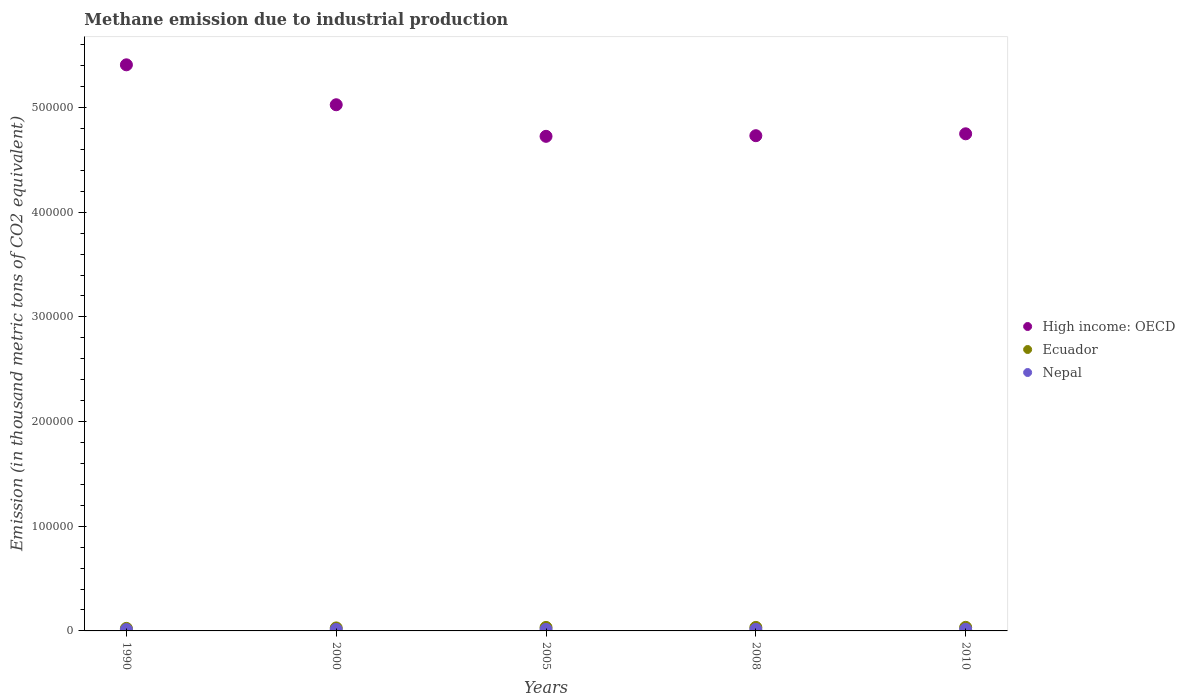What is the amount of methane emitted in High income: OECD in 2005?
Your answer should be compact. 4.73e+05. Across all years, what is the maximum amount of methane emitted in Nepal?
Keep it short and to the point. 1515.7. Across all years, what is the minimum amount of methane emitted in Ecuador?
Make the answer very short. 2418.4. In which year was the amount of methane emitted in High income: OECD minimum?
Give a very brief answer. 2005. What is the total amount of methane emitted in High income: OECD in the graph?
Make the answer very short. 2.46e+06. What is the difference between the amount of methane emitted in Ecuador in 1990 and that in 2005?
Your answer should be very brief. -936.3. What is the difference between the amount of methane emitted in Ecuador in 2000 and the amount of methane emitted in Nepal in 2005?
Offer a terse response. 1430.3. What is the average amount of methane emitted in Ecuador per year?
Make the answer very short. 3085.26. In the year 2000, what is the difference between the amount of methane emitted in Ecuador and amount of methane emitted in Nepal?
Your answer should be compact. 1461. In how many years, is the amount of methane emitted in High income: OECD greater than 520000 thousand metric tons?
Ensure brevity in your answer.  1. What is the ratio of the amount of methane emitted in Nepal in 2000 to that in 2008?
Provide a succinct answer. 0.96. Is the amount of methane emitted in Ecuador in 2008 less than that in 2010?
Make the answer very short. Yes. Is the difference between the amount of methane emitted in Ecuador in 2000 and 2005 greater than the difference between the amount of methane emitted in Nepal in 2000 and 2005?
Offer a terse response. No. What is the difference between the highest and the second highest amount of methane emitted in Nepal?
Keep it short and to the point. 57.1. What is the difference between the highest and the lowest amount of methane emitted in High income: OECD?
Offer a terse response. 6.83e+04. In how many years, is the amount of methane emitted in High income: OECD greater than the average amount of methane emitted in High income: OECD taken over all years?
Ensure brevity in your answer.  2. Is the sum of the amount of methane emitted in Nepal in 2005 and 2010 greater than the maximum amount of methane emitted in Ecuador across all years?
Provide a short and direct response. No. Is the amount of methane emitted in Nepal strictly less than the amount of methane emitted in Ecuador over the years?
Your answer should be compact. Yes. How many dotlines are there?
Provide a short and direct response. 3. How many years are there in the graph?
Ensure brevity in your answer.  5. Does the graph contain grids?
Offer a terse response. No. Where does the legend appear in the graph?
Offer a very short reply. Center right. How are the legend labels stacked?
Your response must be concise. Vertical. What is the title of the graph?
Provide a short and direct response. Methane emission due to industrial production. Does "Sao Tome and Principe" appear as one of the legend labels in the graph?
Make the answer very short. No. What is the label or title of the Y-axis?
Your answer should be very brief. Emission (in thousand metric tons of CO2 equivalent). What is the Emission (in thousand metric tons of CO2 equivalent) in High income: OECD in 1990?
Provide a short and direct response. 5.41e+05. What is the Emission (in thousand metric tons of CO2 equivalent) in Ecuador in 1990?
Your answer should be compact. 2418.4. What is the Emission (in thousand metric tons of CO2 equivalent) in Nepal in 1990?
Offer a terse response. 1296.6. What is the Emission (in thousand metric tons of CO2 equivalent) of High income: OECD in 2000?
Ensure brevity in your answer.  5.03e+05. What is the Emission (in thousand metric tons of CO2 equivalent) in Ecuador in 2000?
Ensure brevity in your answer.  2866.1. What is the Emission (in thousand metric tons of CO2 equivalent) of Nepal in 2000?
Your answer should be very brief. 1405.1. What is the Emission (in thousand metric tons of CO2 equivalent) of High income: OECD in 2005?
Provide a succinct answer. 4.73e+05. What is the Emission (in thousand metric tons of CO2 equivalent) in Ecuador in 2005?
Make the answer very short. 3354.7. What is the Emission (in thousand metric tons of CO2 equivalent) of Nepal in 2005?
Give a very brief answer. 1435.8. What is the Emission (in thousand metric tons of CO2 equivalent) of High income: OECD in 2008?
Provide a short and direct response. 4.73e+05. What is the Emission (in thousand metric tons of CO2 equivalent) of Ecuador in 2008?
Your response must be concise. 3354.3. What is the Emission (in thousand metric tons of CO2 equivalent) in Nepal in 2008?
Keep it short and to the point. 1458.6. What is the Emission (in thousand metric tons of CO2 equivalent) in High income: OECD in 2010?
Your answer should be compact. 4.75e+05. What is the Emission (in thousand metric tons of CO2 equivalent) of Ecuador in 2010?
Your answer should be very brief. 3432.8. What is the Emission (in thousand metric tons of CO2 equivalent) of Nepal in 2010?
Your response must be concise. 1515.7. Across all years, what is the maximum Emission (in thousand metric tons of CO2 equivalent) in High income: OECD?
Provide a short and direct response. 5.41e+05. Across all years, what is the maximum Emission (in thousand metric tons of CO2 equivalent) of Ecuador?
Keep it short and to the point. 3432.8. Across all years, what is the maximum Emission (in thousand metric tons of CO2 equivalent) in Nepal?
Provide a succinct answer. 1515.7. Across all years, what is the minimum Emission (in thousand metric tons of CO2 equivalent) in High income: OECD?
Offer a terse response. 4.73e+05. Across all years, what is the minimum Emission (in thousand metric tons of CO2 equivalent) in Ecuador?
Your response must be concise. 2418.4. Across all years, what is the minimum Emission (in thousand metric tons of CO2 equivalent) in Nepal?
Your response must be concise. 1296.6. What is the total Emission (in thousand metric tons of CO2 equivalent) in High income: OECD in the graph?
Your answer should be very brief. 2.46e+06. What is the total Emission (in thousand metric tons of CO2 equivalent) of Ecuador in the graph?
Provide a short and direct response. 1.54e+04. What is the total Emission (in thousand metric tons of CO2 equivalent) of Nepal in the graph?
Offer a terse response. 7111.8. What is the difference between the Emission (in thousand metric tons of CO2 equivalent) in High income: OECD in 1990 and that in 2000?
Offer a terse response. 3.82e+04. What is the difference between the Emission (in thousand metric tons of CO2 equivalent) in Ecuador in 1990 and that in 2000?
Make the answer very short. -447.7. What is the difference between the Emission (in thousand metric tons of CO2 equivalent) in Nepal in 1990 and that in 2000?
Your response must be concise. -108.5. What is the difference between the Emission (in thousand metric tons of CO2 equivalent) of High income: OECD in 1990 and that in 2005?
Give a very brief answer. 6.83e+04. What is the difference between the Emission (in thousand metric tons of CO2 equivalent) of Ecuador in 1990 and that in 2005?
Your answer should be compact. -936.3. What is the difference between the Emission (in thousand metric tons of CO2 equivalent) of Nepal in 1990 and that in 2005?
Keep it short and to the point. -139.2. What is the difference between the Emission (in thousand metric tons of CO2 equivalent) in High income: OECD in 1990 and that in 2008?
Your response must be concise. 6.77e+04. What is the difference between the Emission (in thousand metric tons of CO2 equivalent) in Ecuador in 1990 and that in 2008?
Make the answer very short. -935.9. What is the difference between the Emission (in thousand metric tons of CO2 equivalent) of Nepal in 1990 and that in 2008?
Keep it short and to the point. -162. What is the difference between the Emission (in thousand metric tons of CO2 equivalent) in High income: OECD in 1990 and that in 2010?
Offer a very short reply. 6.59e+04. What is the difference between the Emission (in thousand metric tons of CO2 equivalent) in Ecuador in 1990 and that in 2010?
Provide a short and direct response. -1014.4. What is the difference between the Emission (in thousand metric tons of CO2 equivalent) of Nepal in 1990 and that in 2010?
Your response must be concise. -219.1. What is the difference between the Emission (in thousand metric tons of CO2 equivalent) in High income: OECD in 2000 and that in 2005?
Offer a very short reply. 3.02e+04. What is the difference between the Emission (in thousand metric tons of CO2 equivalent) of Ecuador in 2000 and that in 2005?
Your response must be concise. -488.6. What is the difference between the Emission (in thousand metric tons of CO2 equivalent) of Nepal in 2000 and that in 2005?
Make the answer very short. -30.7. What is the difference between the Emission (in thousand metric tons of CO2 equivalent) in High income: OECD in 2000 and that in 2008?
Your response must be concise. 2.96e+04. What is the difference between the Emission (in thousand metric tons of CO2 equivalent) in Ecuador in 2000 and that in 2008?
Make the answer very short. -488.2. What is the difference between the Emission (in thousand metric tons of CO2 equivalent) in Nepal in 2000 and that in 2008?
Your response must be concise. -53.5. What is the difference between the Emission (in thousand metric tons of CO2 equivalent) of High income: OECD in 2000 and that in 2010?
Offer a very short reply. 2.78e+04. What is the difference between the Emission (in thousand metric tons of CO2 equivalent) in Ecuador in 2000 and that in 2010?
Ensure brevity in your answer.  -566.7. What is the difference between the Emission (in thousand metric tons of CO2 equivalent) in Nepal in 2000 and that in 2010?
Ensure brevity in your answer.  -110.6. What is the difference between the Emission (in thousand metric tons of CO2 equivalent) in High income: OECD in 2005 and that in 2008?
Provide a short and direct response. -593. What is the difference between the Emission (in thousand metric tons of CO2 equivalent) of Ecuador in 2005 and that in 2008?
Give a very brief answer. 0.4. What is the difference between the Emission (in thousand metric tons of CO2 equivalent) in Nepal in 2005 and that in 2008?
Make the answer very short. -22.8. What is the difference between the Emission (in thousand metric tons of CO2 equivalent) in High income: OECD in 2005 and that in 2010?
Make the answer very short. -2407.6. What is the difference between the Emission (in thousand metric tons of CO2 equivalent) of Ecuador in 2005 and that in 2010?
Keep it short and to the point. -78.1. What is the difference between the Emission (in thousand metric tons of CO2 equivalent) of Nepal in 2005 and that in 2010?
Your answer should be compact. -79.9. What is the difference between the Emission (in thousand metric tons of CO2 equivalent) of High income: OECD in 2008 and that in 2010?
Provide a short and direct response. -1814.6. What is the difference between the Emission (in thousand metric tons of CO2 equivalent) of Ecuador in 2008 and that in 2010?
Your answer should be very brief. -78.5. What is the difference between the Emission (in thousand metric tons of CO2 equivalent) in Nepal in 2008 and that in 2010?
Make the answer very short. -57.1. What is the difference between the Emission (in thousand metric tons of CO2 equivalent) in High income: OECD in 1990 and the Emission (in thousand metric tons of CO2 equivalent) in Ecuador in 2000?
Offer a terse response. 5.38e+05. What is the difference between the Emission (in thousand metric tons of CO2 equivalent) in High income: OECD in 1990 and the Emission (in thousand metric tons of CO2 equivalent) in Nepal in 2000?
Your answer should be very brief. 5.39e+05. What is the difference between the Emission (in thousand metric tons of CO2 equivalent) of Ecuador in 1990 and the Emission (in thousand metric tons of CO2 equivalent) of Nepal in 2000?
Your answer should be compact. 1013.3. What is the difference between the Emission (in thousand metric tons of CO2 equivalent) in High income: OECD in 1990 and the Emission (in thousand metric tons of CO2 equivalent) in Ecuador in 2005?
Your answer should be compact. 5.38e+05. What is the difference between the Emission (in thousand metric tons of CO2 equivalent) in High income: OECD in 1990 and the Emission (in thousand metric tons of CO2 equivalent) in Nepal in 2005?
Offer a terse response. 5.39e+05. What is the difference between the Emission (in thousand metric tons of CO2 equivalent) in Ecuador in 1990 and the Emission (in thousand metric tons of CO2 equivalent) in Nepal in 2005?
Your answer should be very brief. 982.6. What is the difference between the Emission (in thousand metric tons of CO2 equivalent) of High income: OECD in 1990 and the Emission (in thousand metric tons of CO2 equivalent) of Ecuador in 2008?
Provide a short and direct response. 5.38e+05. What is the difference between the Emission (in thousand metric tons of CO2 equivalent) of High income: OECD in 1990 and the Emission (in thousand metric tons of CO2 equivalent) of Nepal in 2008?
Keep it short and to the point. 5.39e+05. What is the difference between the Emission (in thousand metric tons of CO2 equivalent) of Ecuador in 1990 and the Emission (in thousand metric tons of CO2 equivalent) of Nepal in 2008?
Provide a succinct answer. 959.8. What is the difference between the Emission (in thousand metric tons of CO2 equivalent) of High income: OECD in 1990 and the Emission (in thousand metric tons of CO2 equivalent) of Ecuador in 2010?
Your answer should be compact. 5.37e+05. What is the difference between the Emission (in thousand metric tons of CO2 equivalent) in High income: OECD in 1990 and the Emission (in thousand metric tons of CO2 equivalent) in Nepal in 2010?
Your answer should be compact. 5.39e+05. What is the difference between the Emission (in thousand metric tons of CO2 equivalent) of Ecuador in 1990 and the Emission (in thousand metric tons of CO2 equivalent) of Nepal in 2010?
Make the answer very short. 902.7. What is the difference between the Emission (in thousand metric tons of CO2 equivalent) of High income: OECD in 2000 and the Emission (in thousand metric tons of CO2 equivalent) of Ecuador in 2005?
Provide a short and direct response. 4.99e+05. What is the difference between the Emission (in thousand metric tons of CO2 equivalent) of High income: OECD in 2000 and the Emission (in thousand metric tons of CO2 equivalent) of Nepal in 2005?
Offer a terse response. 5.01e+05. What is the difference between the Emission (in thousand metric tons of CO2 equivalent) of Ecuador in 2000 and the Emission (in thousand metric tons of CO2 equivalent) of Nepal in 2005?
Ensure brevity in your answer.  1430.3. What is the difference between the Emission (in thousand metric tons of CO2 equivalent) in High income: OECD in 2000 and the Emission (in thousand metric tons of CO2 equivalent) in Ecuador in 2008?
Keep it short and to the point. 4.99e+05. What is the difference between the Emission (in thousand metric tons of CO2 equivalent) of High income: OECD in 2000 and the Emission (in thousand metric tons of CO2 equivalent) of Nepal in 2008?
Offer a terse response. 5.01e+05. What is the difference between the Emission (in thousand metric tons of CO2 equivalent) of Ecuador in 2000 and the Emission (in thousand metric tons of CO2 equivalent) of Nepal in 2008?
Provide a succinct answer. 1407.5. What is the difference between the Emission (in thousand metric tons of CO2 equivalent) of High income: OECD in 2000 and the Emission (in thousand metric tons of CO2 equivalent) of Ecuador in 2010?
Ensure brevity in your answer.  4.99e+05. What is the difference between the Emission (in thousand metric tons of CO2 equivalent) in High income: OECD in 2000 and the Emission (in thousand metric tons of CO2 equivalent) in Nepal in 2010?
Provide a short and direct response. 5.01e+05. What is the difference between the Emission (in thousand metric tons of CO2 equivalent) in Ecuador in 2000 and the Emission (in thousand metric tons of CO2 equivalent) in Nepal in 2010?
Offer a very short reply. 1350.4. What is the difference between the Emission (in thousand metric tons of CO2 equivalent) of High income: OECD in 2005 and the Emission (in thousand metric tons of CO2 equivalent) of Ecuador in 2008?
Make the answer very short. 4.69e+05. What is the difference between the Emission (in thousand metric tons of CO2 equivalent) of High income: OECD in 2005 and the Emission (in thousand metric tons of CO2 equivalent) of Nepal in 2008?
Offer a terse response. 4.71e+05. What is the difference between the Emission (in thousand metric tons of CO2 equivalent) of Ecuador in 2005 and the Emission (in thousand metric tons of CO2 equivalent) of Nepal in 2008?
Ensure brevity in your answer.  1896.1. What is the difference between the Emission (in thousand metric tons of CO2 equivalent) in High income: OECD in 2005 and the Emission (in thousand metric tons of CO2 equivalent) in Ecuador in 2010?
Your response must be concise. 4.69e+05. What is the difference between the Emission (in thousand metric tons of CO2 equivalent) of High income: OECD in 2005 and the Emission (in thousand metric tons of CO2 equivalent) of Nepal in 2010?
Keep it short and to the point. 4.71e+05. What is the difference between the Emission (in thousand metric tons of CO2 equivalent) in Ecuador in 2005 and the Emission (in thousand metric tons of CO2 equivalent) in Nepal in 2010?
Provide a succinct answer. 1839. What is the difference between the Emission (in thousand metric tons of CO2 equivalent) of High income: OECD in 2008 and the Emission (in thousand metric tons of CO2 equivalent) of Ecuador in 2010?
Provide a succinct answer. 4.70e+05. What is the difference between the Emission (in thousand metric tons of CO2 equivalent) of High income: OECD in 2008 and the Emission (in thousand metric tons of CO2 equivalent) of Nepal in 2010?
Offer a very short reply. 4.72e+05. What is the difference between the Emission (in thousand metric tons of CO2 equivalent) of Ecuador in 2008 and the Emission (in thousand metric tons of CO2 equivalent) of Nepal in 2010?
Provide a short and direct response. 1838.6. What is the average Emission (in thousand metric tons of CO2 equivalent) of High income: OECD per year?
Your answer should be very brief. 4.93e+05. What is the average Emission (in thousand metric tons of CO2 equivalent) in Ecuador per year?
Keep it short and to the point. 3085.26. What is the average Emission (in thousand metric tons of CO2 equivalent) of Nepal per year?
Keep it short and to the point. 1422.36. In the year 1990, what is the difference between the Emission (in thousand metric tons of CO2 equivalent) in High income: OECD and Emission (in thousand metric tons of CO2 equivalent) in Ecuador?
Your answer should be very brief. 5.38e+05. In the year 1990, what is the difference between the Emission (in thousand metric tons of CO2 equivalent) in High income: OECD and Emission (in thousand metric tons of CO2 equivalent) in Nepal?
Offer a very short reply. 5.40e+05. In the year 1990, what is the difference between the Emission (in thousand metric tons of CO2 equivalent) of Ecuador and Emission (in thousand metric tons of CO2 equivalent) of Nepal?
Ensure brevity in your answer.  1121.8. In the year 2000, what is the difference between the Emission (in thousand metric tons of CO2 equivalent) of High income: OECD and Emission (in thousand metric tons of CO2 equivalent) of Ecuador?
Your answer should be compact. 5.00e+05. In the year 2000, what is the difference between the Emission (in thousand metric tons of CO2 equivalent) of High income: OECD and Emission (in thousand metric tons of CO2 equivalent) of Nepal?
Your answer should be very brief. 5.01e+05. In the year 2000, what is the difference between the Emission (in thousand metric tons of CO2 equivalent) of Ecuador and Emission (in thousand metric tons of CO2 equivalent) of Nepal?
Offer a terse response. 1461. In the year 2005, what is the difference between the Emission (in thousand metric tons of CO2 equivalent) of High income: OECD and Emission (in thousand metric tons of CO2 equivalent) of Ecuador?
Keep it short and to the point. 4.69e+05. In the year 2005, what is the difference between the Emission (in thousand metric tons of CO2 equivalent) of High income: OECD and Emission (in thousand metric tons of CO2 equivalent) of Nepal?
Provide a succinct answer. 4.71e+05. In the year 2005, what is the difference between the Emission (in thousand metric tons of CO2 equivalent) in Ecuador and Emission (in thousand metric tons of CO2 equivalent) in Nepal?
Ensure brevity in your answer.  1918.9. In the year 2008, what is the difference between the Emission (in thousand metric tons of CO2 equivalent) in High income: OECD and Emission (in thousand metric tons of CO2 equivalent) in Ecuador?
Give a very brief answer. 4.70e+05. In the year 2008, what is the difference between the Emission (in thousand metric tons of CO2 equivalent) of High income: OECD and Emission (in thousand metric tons of CO2 equivalent) of Nepal?
Provide a short and direct response. 4.72e+05. In the year 2008, what is the difference between the Emission (in thousand metric tons of CO2 equivalent) in Ecuador and Emission (in thousand metric tons of CO2 equivalent) in Nepal?
Offer a very short reply. 1895.7. In the year 2010, what is the difference between the Emission (in thousand metric tons of CO2 equivalent) of High income: OECD and Emission (in thousand metric tons of CO2 equivalent) of Ecuador?
Your answer should be very brief. 4.72e+05. In the year 2010, what is the difference between the Emission (in thousand metric tons of CO2 equivalent) of High income: OECD and Emission (in thousand metric tons of CO2 equivalent) of Nepal?
Keep it short and to the point. 4.73e+05. In the year 2010, what is the difference between the Emission (in thousand metric tons of CO2 equivalent) of Ecuador and Emission (in thousand metric tons of CO2 equivalent) of Nepal?
Your answer should be very brief. 1917.1. What is the ratio of the Emission (in thousand metric tons of CO2 equivalent) in High income: OECD in 1990 to that in 2000?
Make the answer very short. 1.08. What is the ratio of the Emission (in thousand metric tons of CO2 equivalent) in Ecuador in 1990 to that in 2000?
Your response must be concise. 0.84. What is the ratio of the Emission (in thousand metric tons of CO2 equivalent) of Nepal in 1990 to that in 2000?
Keep it short and to the point. 0.92. What is the ratio of the Emission (in thousand metric tons of CO2 equivalent) of High income: OECD in 1990 to that in 2005?
Offer a very short reply. 1.14. What is the ratio of the Emission (in thousand metric tons of CO2 equivalent) of Ecuador in 1990 to that in 2005?
Your answer should be compact. 0.72. What is the ratio of the Emission (in thousand metric tons of CO2 equivalent) in Nepal in 1990 to that in 2005?
Your answer should be compact. 0.9. What is the ratio of the Emission (in thousand metric tons of CO2 equivalent) in High income: OECD in 1990 to that in 2008?
Give a very brief answer. 1.14. What is the ratio of the Emission (in thousand metric tons of CO2 equivalent) of Ecuador in 1990 to that in 2008?
Give a very brief answer. 0.72. What is the ratio of the Emission (in thousand metric tons of CO2 equivalent) in High income: OECD in 1990 to that in 2010?
Ensure brevity in your answer.  1.14. What is the ratio of the Emission (in thousand metric tons of CO2 equivalent) of Ecuador in 1990 to that in 2010?
Ensure brevity in your answer.  0.7. What is the ratio of the Emission (in thousand metric tons of CO2 equivalent) in Nepal in 1990 to that in 2010?
Provide a short and direct response. 0.86. What is the ratio of the Emission (in thousand metric tons of CO2 equivalent) in High income: OECD in 2000 to that in 2005?
Keep it short and to the point. 1.06. What is the ratio of the Emission (in thousand metric tons of CO2 equivalent) of Ecuador in 2000 to that in 2005?
Provide a succinct answer. 0.85. What is the ratio of the Emission (in thousand metric tons of CO2 equivalent) of Nepal in 2000 to that in 2005?
Provide a succinct answer. 0.98. What is the ratio of the Emission (in thousand metric tons of CO2 equivalent) of High income: OECD in 2000 to that in 2008?
Offer a very short reply. 1.06. What is the ratio of the Emission (in thousand metric tons of CO2 equivalent) in Ecuador in 2000 to that in 2008?
Ensure brevity in your answer.  0.85. What is the ratio of the Emission (in thousand metric tons of CO2 equivalent) of Nepal in 2000 to that in 2008?
Your response must be concise. 0.96. What is the ratio of the Emission (in thousand metric tons of CO2 equivalent) in High income: OECD in 2000 to that in 2010?
Your response must be concise. 1.06. What is the ratio of the Emission (in thousand metric tons of CO2 equivalent) of Ecuador in 2000 to that in 2010?
Offer a very short reply. 0.83. What is the ratio of the Emission (in thousand metric tons of CO2 equivalent) of Nepal in 2000 to that in 2010?
Your answer should be very brief. 0.93. What is the ratio of the Emission (in thousand metric tons of CO2 equivalent) of Ecuador in 2005 to that in 2008?
Provide a short and direct response. 1. What is the ratio of the Emission (in thousand metric tons of CO2 equivalent) in Nepal in 2005 to that in 2008?
Ensure brevity in your answer.  0.98. What is the ratio of the Emission (in thousand metric tons of CO2 equivalent) of High income: OECD in 2005 to that in 2010?
Ensure brevity in your answer.  0.99. What is the ratio of the Emission (in thousand metric tons of CO2 equivalent) in Ecuador in 2005 to that in 2010?
Give a very brief answer. 0.98. What is the ratio of the Emission (in thousand metric tons of CO2 equivalent) of Nepal in 2005 to that in 2010?
Offer a terse response. 0.95. What is the ratio of the Emission (in thousand metric tons of CO2 equivalent) of High income: OECD in 2008 to that in 2010?
Provide a succinct answer. 1. What is the ratio of the Emission (in thousand metric tons of CO2 equivalent) in Ecuador in 2008 to that in 2010?
Make the answer very short. 0.98. What is the ratio of the Emission (in thousand metric tons of CO2 equivalent) of Nepal in 2008 to that in 2010?
Ensure brevity in your answer.  0.96. What is the difference between the highest and the second highest Emission (in thousand metric tons of CO2 equivalent) in High income: OECD?
Your answer should be compact. 3.82e+04. What is the difference between the highest and the second highest Emission (in thousand metric tons of CO2 equivalent) in Ecuador?
Your response must be concise. 78.1. What is the difference between the highest and the second highest Emission (in thousand metric tons of CO2 equivalent) of Nepal?
Your response must be concise. 57.1. What is the difference between the highest and the lowest Emission (in thousand metric tons of CO2 equivalent) in High income: OECD?
Make the answer very short. 6.83e+04. What is the difference between the highest and the lowest Emission (in thousand metric tons of CO2 equivalent) in Ecuador?
Give a very brief answer. 1014.4. What is the difference between the highest and the lowest Emission (in thousand metric tons of CO2 equivalent) in Nepal?
Your answer should be very brief. 219.1. 